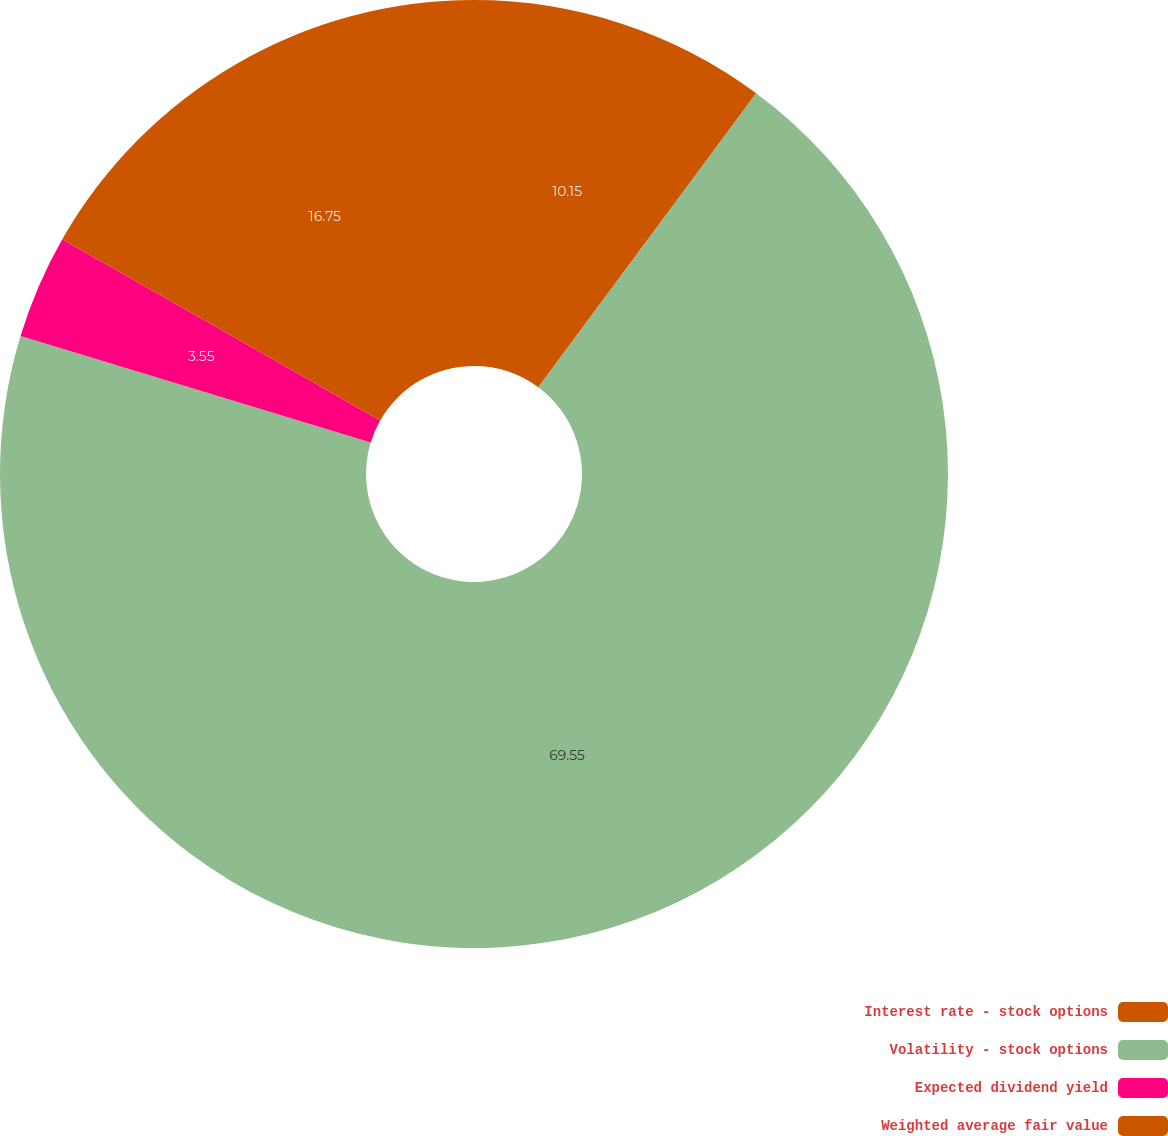<chart> <loc_0><loc_0><loc_500><loc_500><pie_chart><fcel>Interest rate - stock options<fcel>Volatility - stock options<fcel>Expected dividend yield<fcel>Weighted average fair value<nl><fcel>10.15%<fcel>69.55%<fcel>3.55%<fcel>16.75%<nl></chart> 